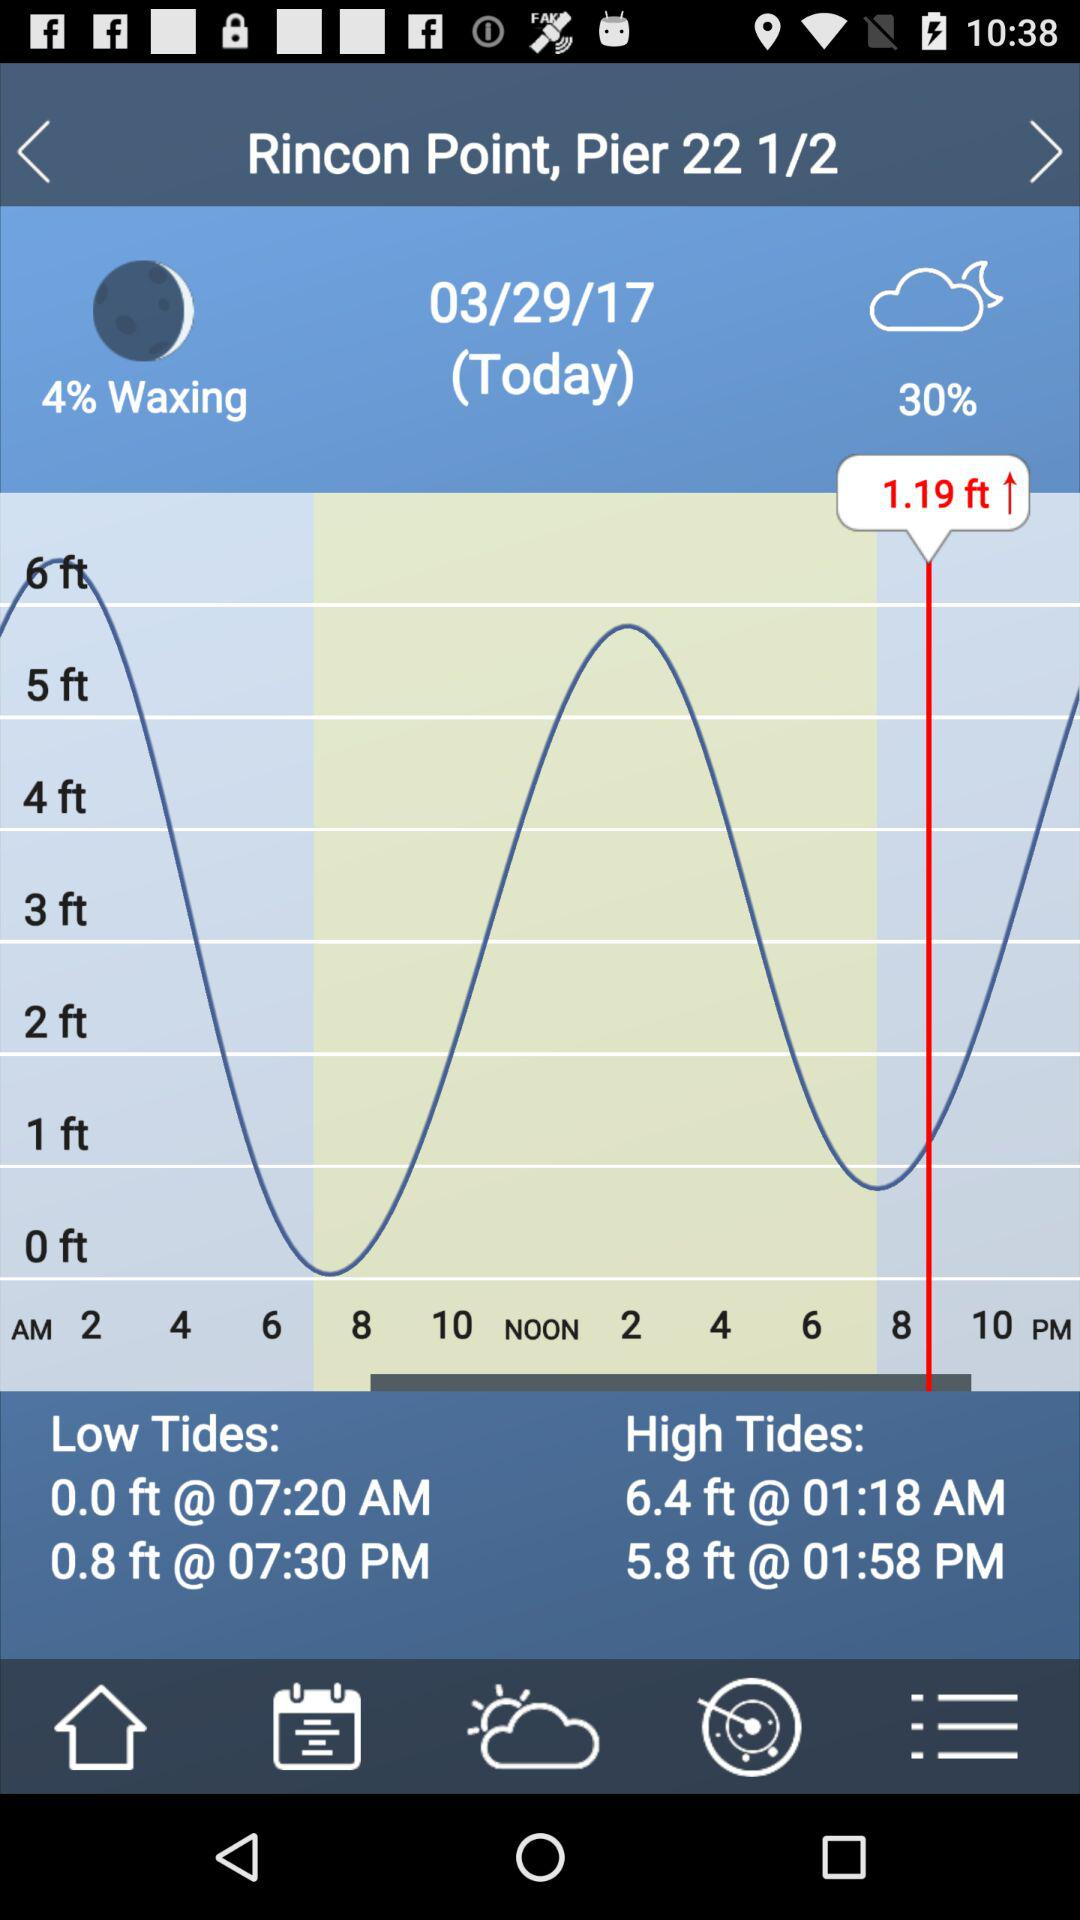What is the mentioned height of high tides? The mentioned heights are 6.4 feet and 5.8 feet. 